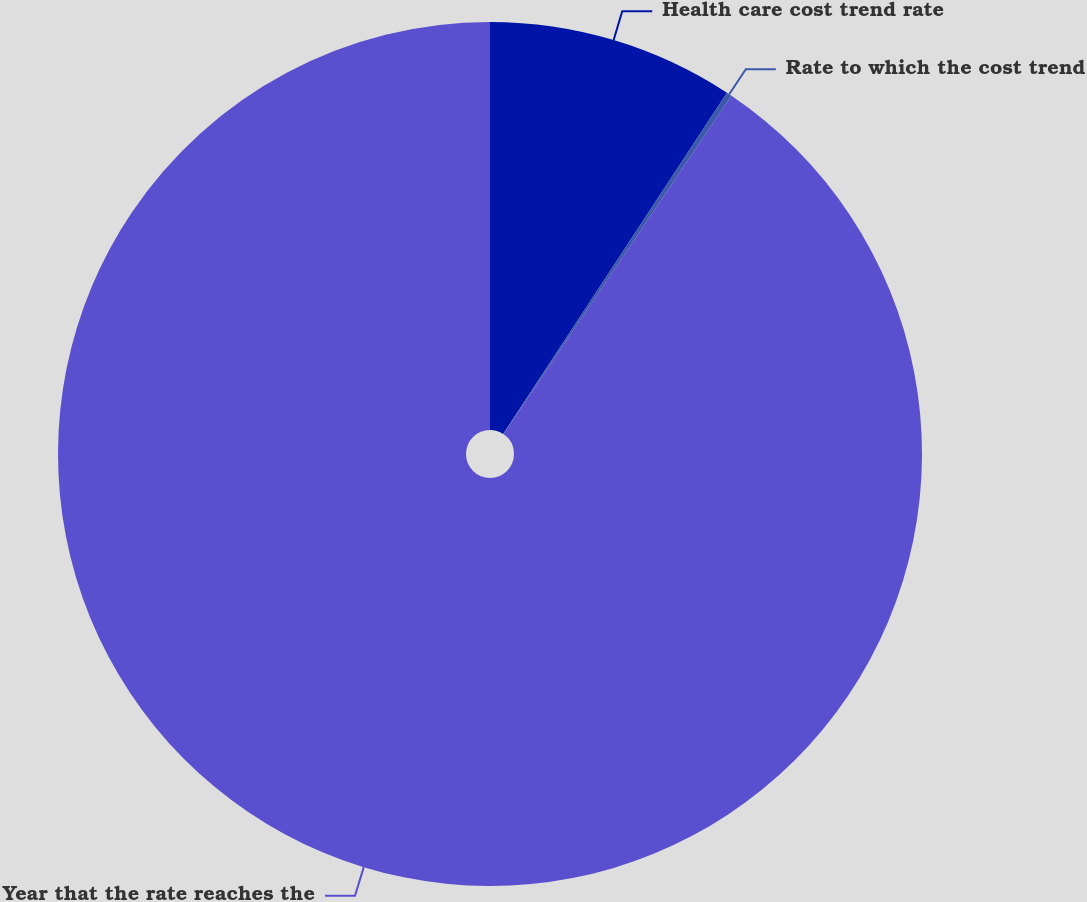Convert chart to OTSL. <chart><loc_0><loc_0><loc_500><loc_500><pie_chart><fcel>Health care cost trend rate<fcel>Rate to which the cost trend<fcel>Year that the rate reaches the<nl><fcel>9.24%<fcel>0.2%<fcel>90.56%<nl></chart> 